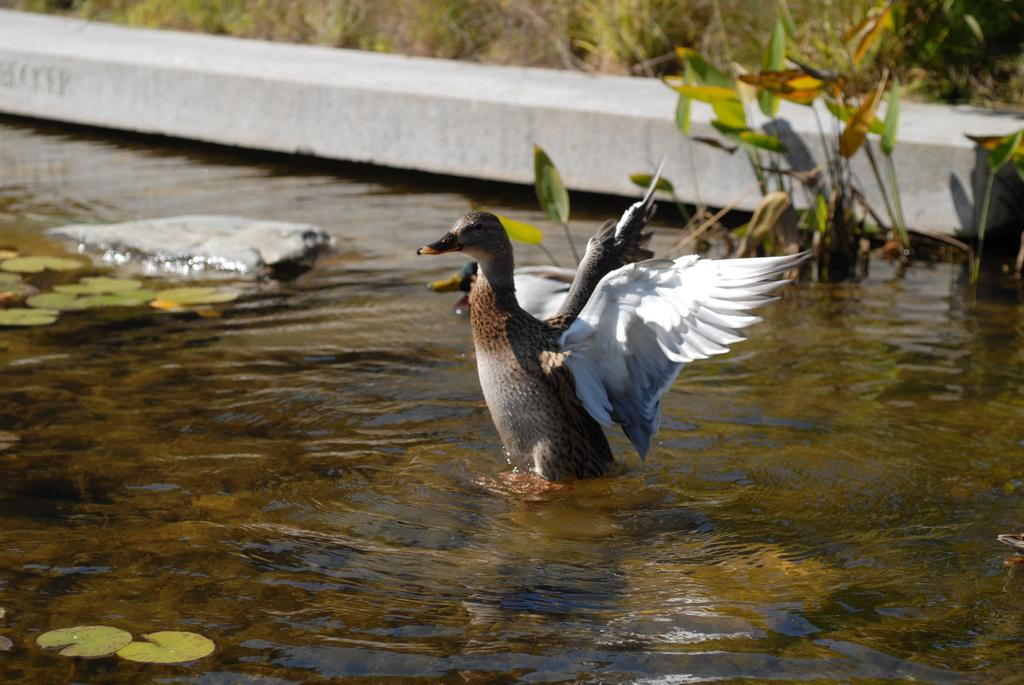What animals are present in the image? There are ducks in the image. Where are the ducks located in the image? The ducks are in the front of the image. What is at the bottom of the image? There is water at the bottom of the image. What can be seen in the background of the image? There are plants in the background of the image. Can you see any fangs on the ducks in the image? No, ducks do not have fangs, so there are no fangs visible in the image. 